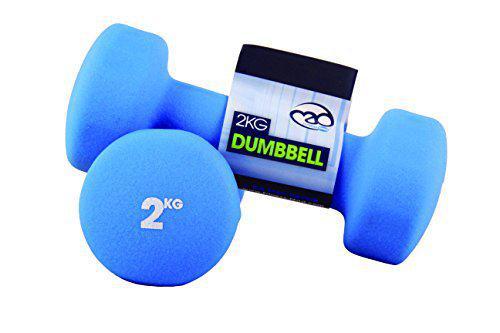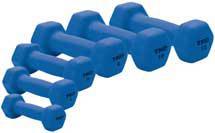The first image is the image on the left, the second image is the image on the right. For the images displayed, is the sentence "All of the weights in the image on the right are completely blue in color." factually correct? Answer yes or no. Yes. The first image is the image on the left, the second image is the image on the right. Examine the images to the left and right. Is the description "A row of six dumbbells appears in one image, arranged in a sequence from least to most weight." accurate? Answer yes or no. Yes. 